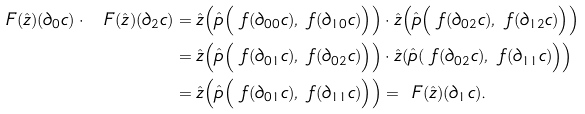<formula> <loc_0><loc_0><loc_500><loc_500>\ F ( \hat { z } ) ( \partial _ { 0 } c ) \cdot \ F ( \hat { z } ) ( \partial _ { 2 } c ) & = \hat { z } \Big ( \hat { p } \Big ( \ f ( \partial _ { 0 0 } c ) , \ f ( \partial _ { 1 0 } c ) \Big ) \Big ) \cdot \hat { z } \Big ( \hat { p } \Big ( \ f ( \partial _ { 0 2 } c ) , \ f ( \partial _ { 1 2 } c ) \Big ) \Big ) \\ & = \hat { z } \Big ( \hat { p } \Big ( \ f ( \partial _ { 0 1 } c ) , \ f ( \partial _ { 0 2 } c ) \Big ) \Big ) \cdot \hat { z } ( \hat { p } ( \ f ( \partial _ { 0 2 } c ) , \ f ( \partial _ { 1 1 } c ) \Big ) \Big ) \\ & = \hat { z } \Big ( \hat { p } \Big ( \ f ( \partial _ { 0 1 } c ) , \ f ( \partial _ { 1 1 } c ) \Big ) \Big ) = \ F ( \hat { z } ) ( \partial _ { 1 } c ) \text {.}</formula> 